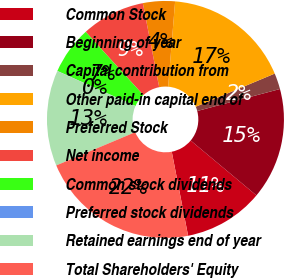Convert chart. <chart><loc_0><loc_0><loc_500><loc_500><pie_chart><fcel>Common Stock<fcel>Beginning of year<fcel>Capital contribution from<fcel>Other paid-in capital end of<fcel>Preferred Stock<fcel>Net income<fcel>Common stock dividends<fcel>Preferred stock dividends<fcel>Retained earnings end of year<fcel>Total Shareholders' Equity<nl><fcel>10.87%<fcel>15.21%<fcel>2.19%<fcel>17.38%<fcel>4.36%<fcel>8.7%<fcel>6.53%<fcel>0.02%<fcel>13.04%<fcel>21.72%<nl></chart> 